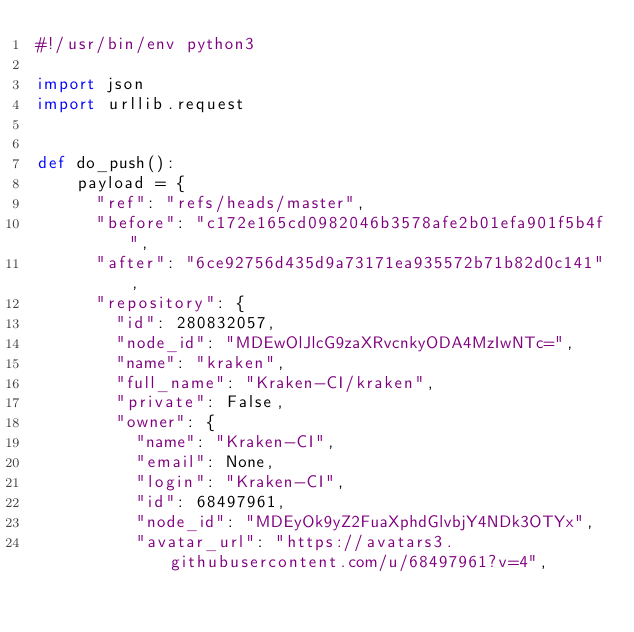<code> <loc_0><loc_0><loc_500><loc_500><_Python_>#!/usr/bin/env python3

import json
import urllib.request


def do_push():
    payload = {
      "ref": "refs/heads/master",
      "before": "c172e165cd0982046b3578afe2b01efa901f5b4f",
      "after": "6ce92756d435d9a73171ea935572b71b82d0c141",
      "repository": {
        "id": 280832057,
        "node_id": "MDEwOlJlcG9zaXRvcnkyODA4MzIwNTc=",
        "name": "kraken",
        "full_name": "Kraken-CI/kraken",
        "private": False,
        "owner": {
          "name": "Kraken-CI",
          "email": None,
          "login": "Kraken-CI",
          "id": 68497961,
          "node_id": "MDEyOk9yZ2FuaXphdGlvbjY4NDk3OTYx",
          "avatar_url": "https://avatars3.githubusercontent.com/u/68497961?v=4",</code> 